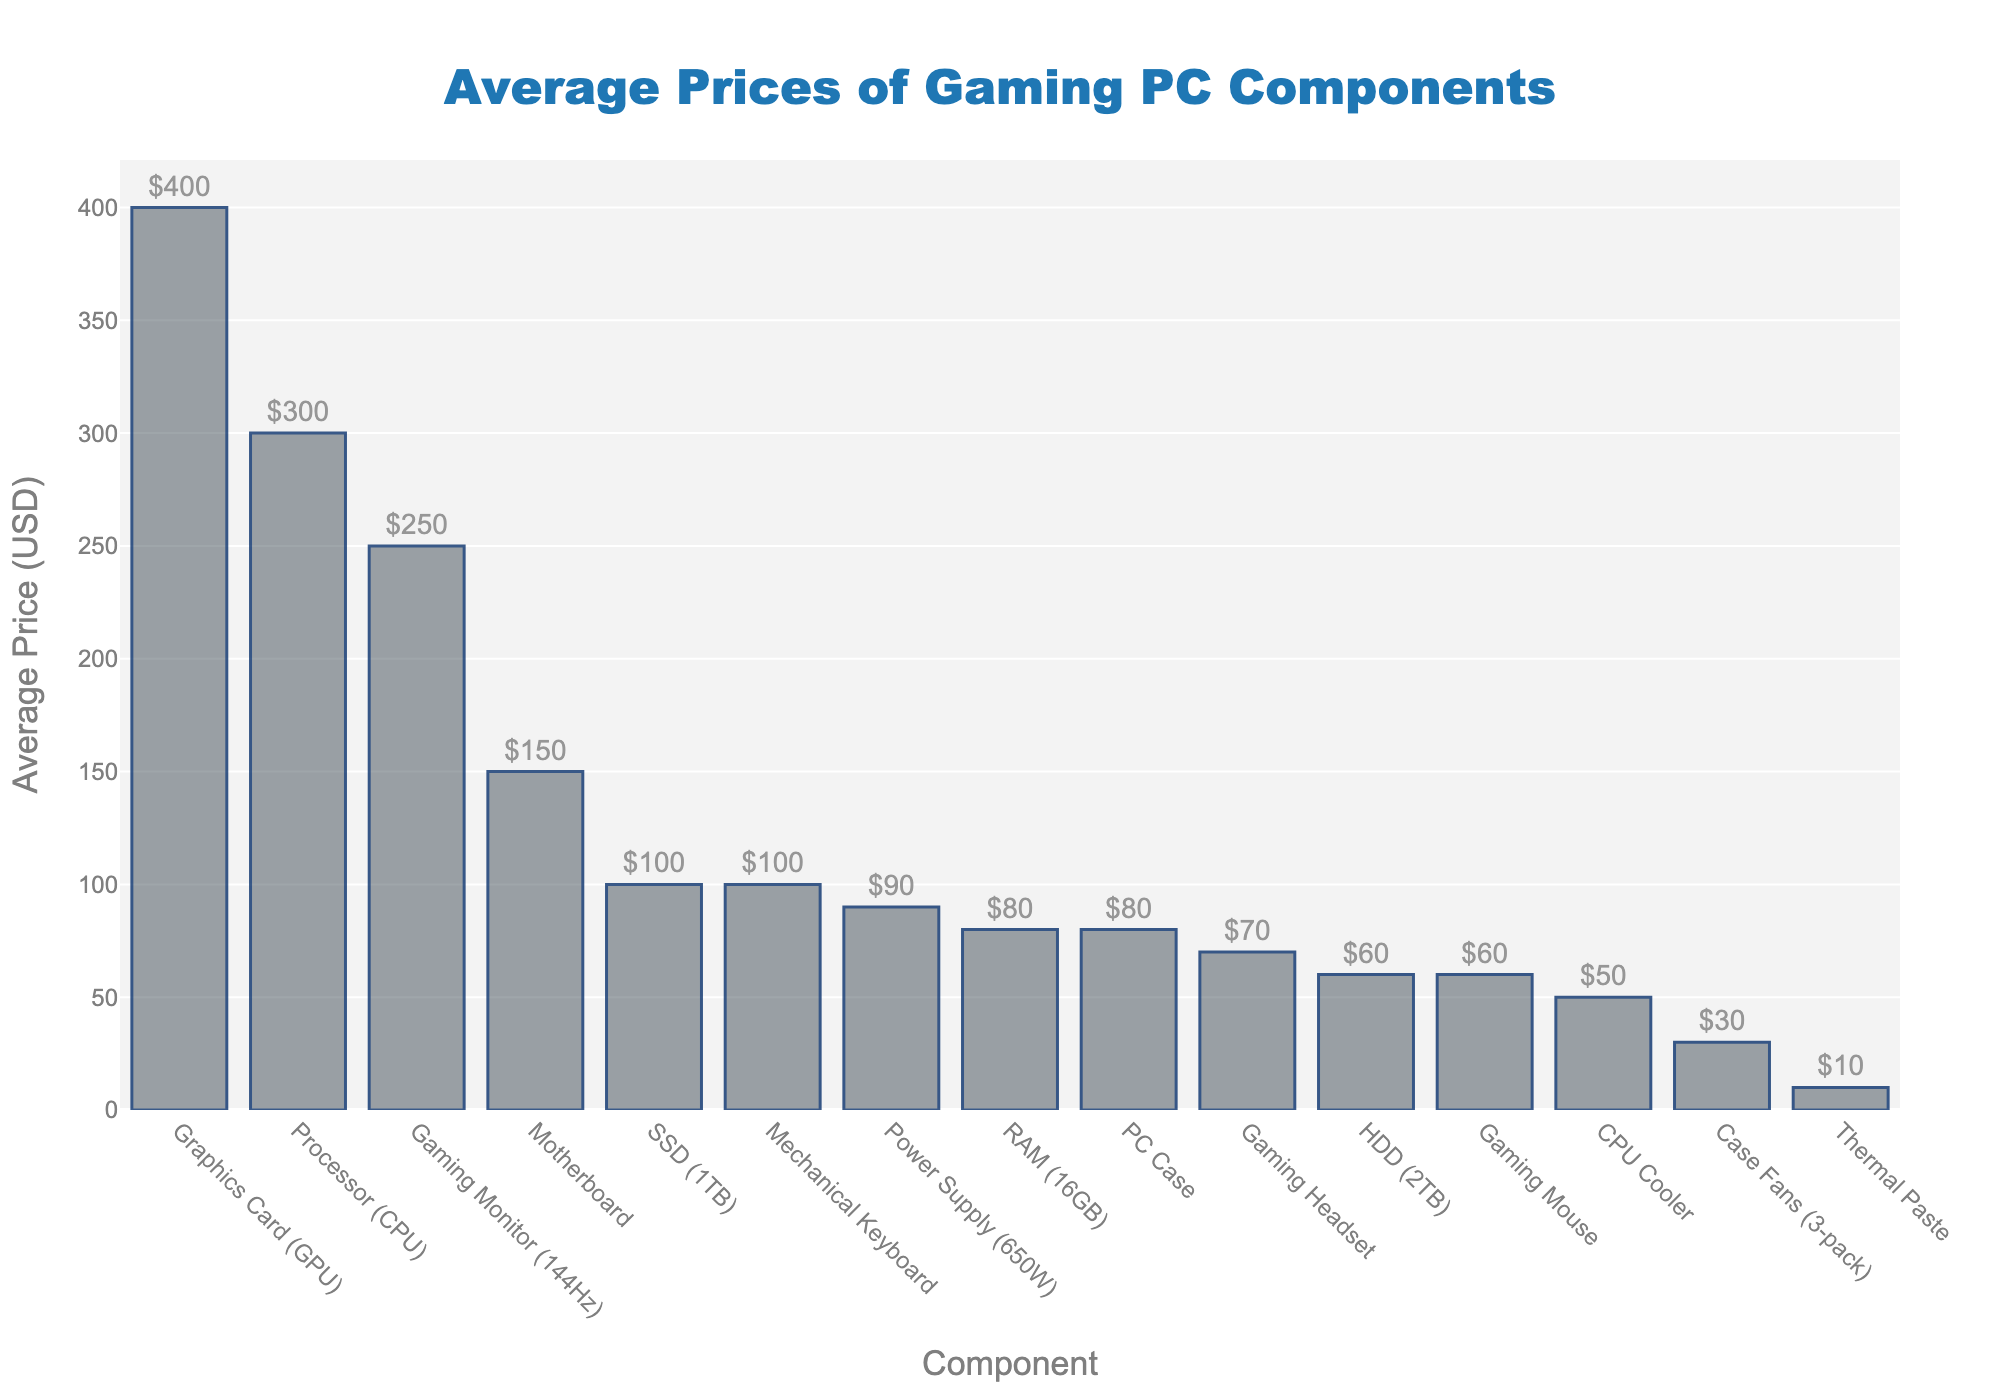What are the most and least expensive components? The bar chart shows the "Graphics Card (GPU)" as the tallest bar at $400, indicating it is the most expensive. The shortest bar, "Thermal Paste," is priced at $10, making it the least expensive.
Answer: GPU, $400 and Thermal Paste, $10 Which component costs more, the gaming monitor or the mechanical keyboard? Comparing the heights of the bars for "Gaming Monitor (144Hz)" and "Mechanical Keyboard," the monitor's bar is taller and labeled $250, whereas the keyboard’s bar is labeled $100.
Answer: Monitor, $250 What is the total cost of the SSD and Power Supply? Look at the heights of the "SSD (1TB)" and "Power Supply (650W)" bars, which are labeled $100 and $90, respectively. Adding them together: $100 + $90 = $190.
Answer: $190 Which components have a price between $50 and $150? Observe the bars that fall within the range of $50 to $150. The components include "Motherboard" ($150), "RAM (16GB)" ($80), "SSD (1TB)" ($100), "Power Supply (650W)" ($90), "PC Case" ($80), "HDD (2TB)" ($60), "Gaming Mouse" ($60), "Gaming Headset" ($70), and "CPU Cooler" ($50).
Answer: Motherboard, RAM, SSD, Power Supply, PC Case, HDD, Gaming Mouse, Gaming Headset, CPU Cooler Which component has a price closest to the median of all the listed components? First, determine the number of components (15) and find the median position, which is the 8th value in sorted order. Sorted prices are: $10, $30, $50, $60, $60, $70, $80, $80, $90, $100, $100, $150, $250, $300, $400. The median is between the 7th and 8th values, both $80. The components priced at $80 are "RAM (16GB)" and "PC Case."
Answer: RAM, PC Case Is the combined price of the CPU and gaming monitor higher than the GPU? Summing the prices of "Processor (CPU)" ($300) and "Gaming Monitor (144Hz)" ($250) gives $550. This is compared to the "Graphics Card (GPU)" which is $400. Since $550 > $400, the combined price is higher.
Answer: Yes How much more expensive is the CPU compared to the HDD? Subtract the price of "HDD (2TB)" ($60) from "Processor (CPU)" ($300): $300 - $60 = $240.
Answer: $240 